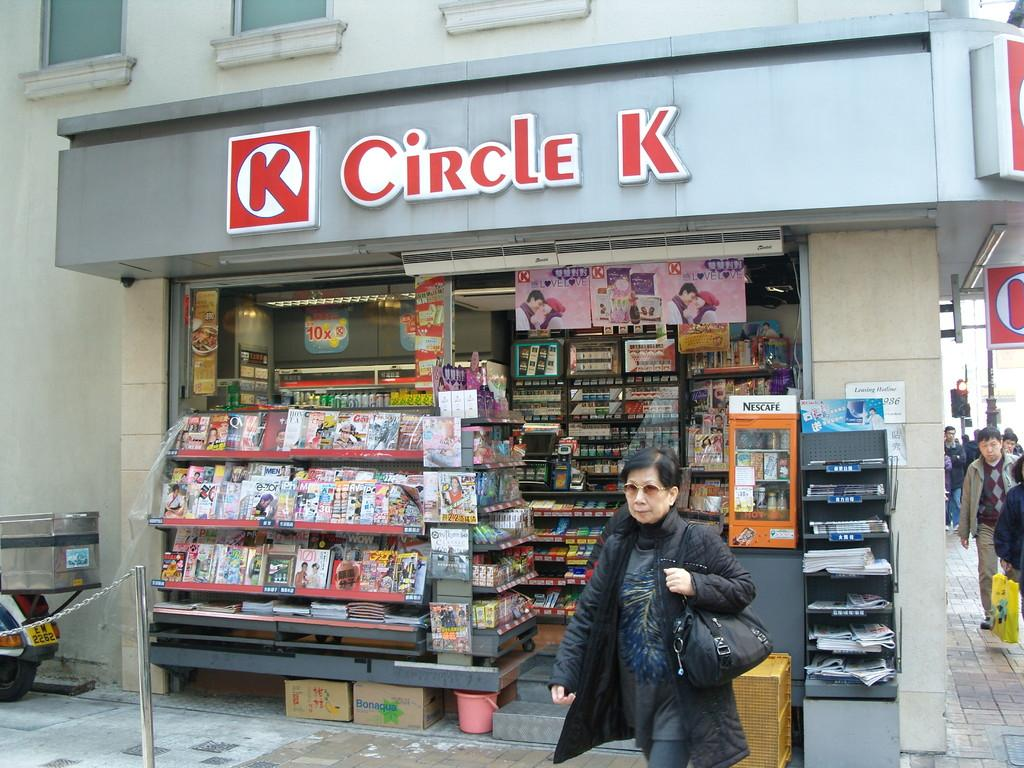<image>
Write a terse but informative summary of the picture. Circle K store front with people walking in front. 